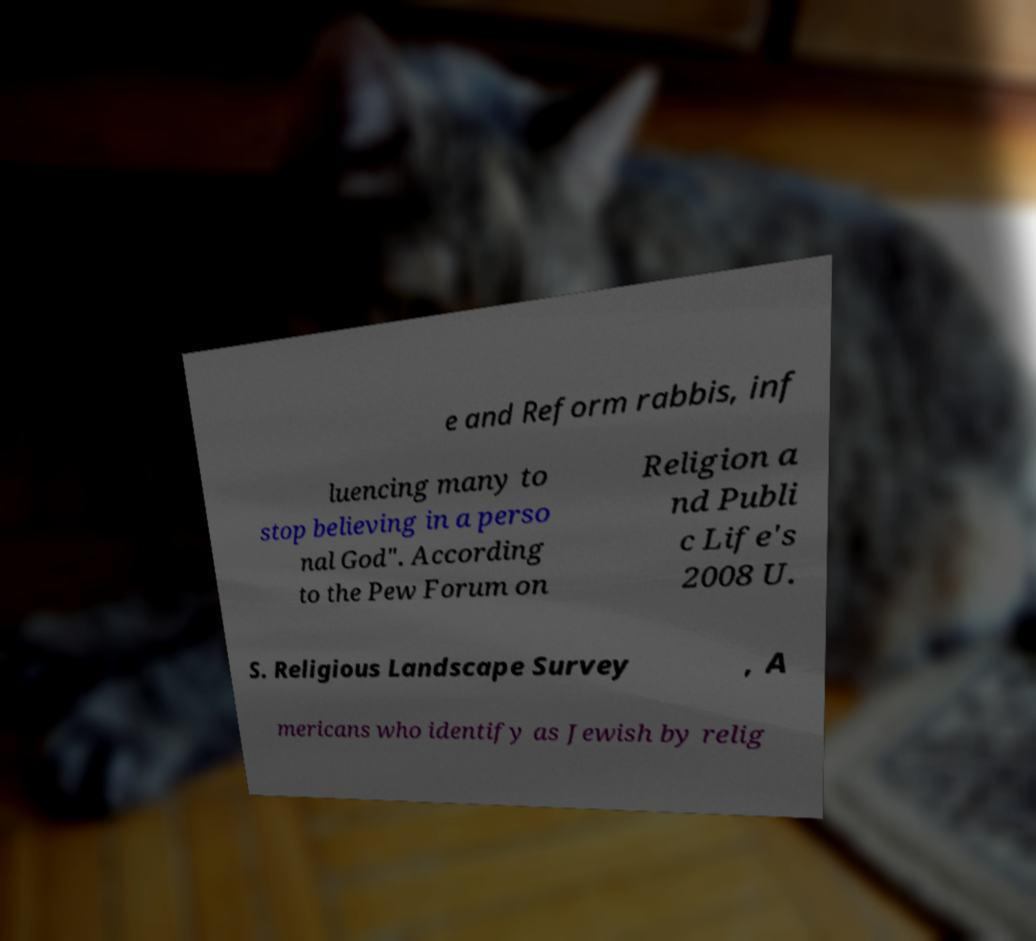What messages or text are displayed in this image? I need them in a readable, typed format. e and Reform rabbis, inf luencing many to stop believing in a perso nal God". According to the Pew Forum on Religion a nd Publi c Life's 2008 U. S. Religious Landscape Survey , A mericans who identify as Jewish by relig 